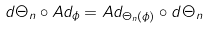<formula> <loc_0><loc_0><loc_500><loc_500>d \Theta _ { n } \circ A d _ { \phi } = A d _ { \Theta _ { n } ( \phi ) } \circ d \Theta _ { n }</formula> 